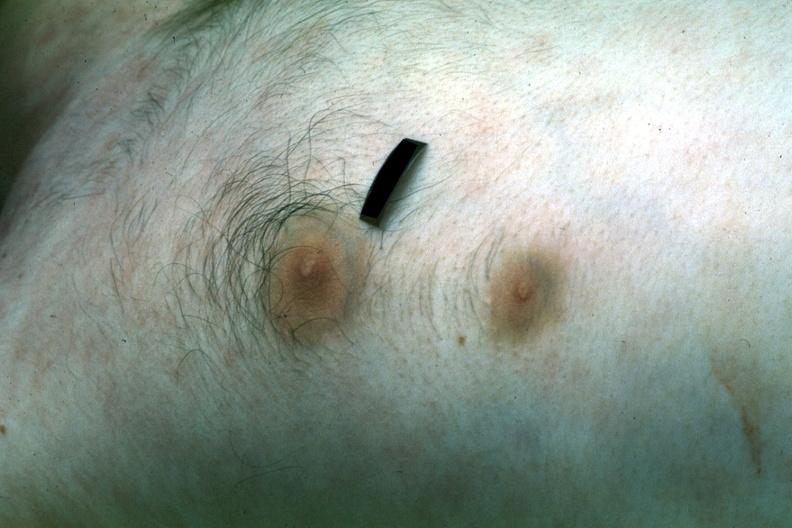does omentum show two nipples?
Answer the question using a single word or phrase. No 